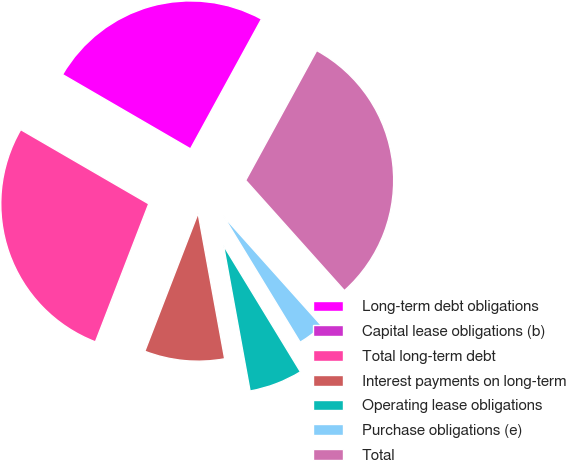Convert chart to OTSL. <chart><loc_0><loc_0><loc_500><loc_500><pie_chart><fcel>Long-term debt obligations<fcel>Capital lease obligations (b)<fcel>Total long-term debt<fcel>Interest payments on long-term<fcel>Operating lease obligations<fcel>Purchase obligations (e)<fcel>Total<nl><fcel>24.59%<fcel>0.01%<fcel>27.5%<fcel>8.74%<fcel>5.83%<fcel>2.92%<fcel>30.41%<nl></chart> 